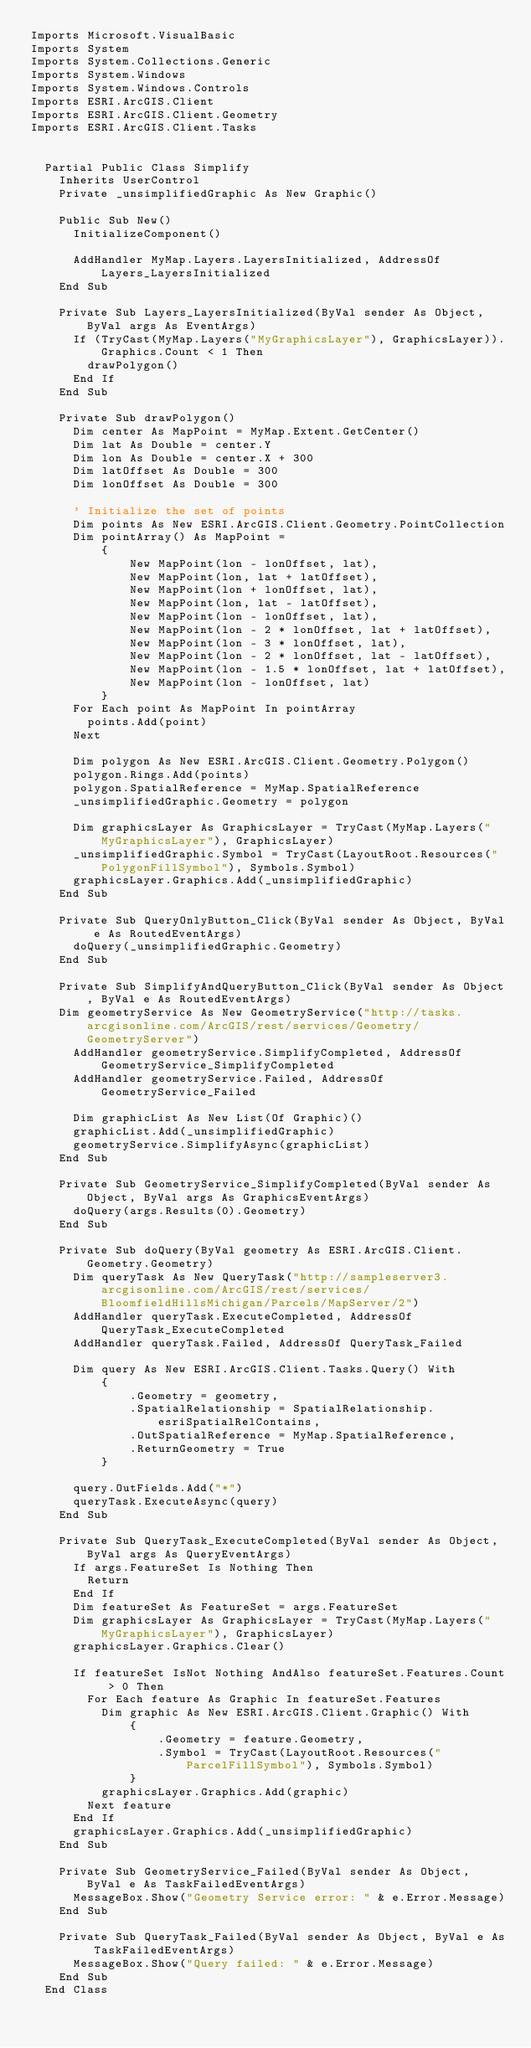<code> <loc_0><loc_0><loc_500><loc_500><_VisualBasic_>Imports Microsoft.VisualBasic
Imports System
Imports System.Collections.Generic
Imports System.Windows
Imports System.Windows.Controls
Imports ESRI.ArcGIS.Client
Imports ESRI.ArcGIS.Client.Geometry
Imports ESRI.ArcGIS.Client.Tasks


  Partial Public Class Simplify
    Inherits UserControl
    Private _unsimplifiedGraphic As New Graphic()

    Public Sub New()
      InitializeComponent()

      AddHandler MyMap.Layers.LayersInitialized, AddressOf Layers_LayersInitialized
    End Sub

    Private Sub Layers_LayersInitialized(ByVal sender As Object, ByVal args As EventArgs)
      If (TryCast(MyMap.Layers("MyGraphicsLayer"), GraphicsLayer)).Graphics.Count < 1 Then
        drawPolygon()
      End If
    End Sub

    Private Sub drawPolygon()
      Dim center As MapPoint = MyMap.Extent.GetCenter()
      Dim lat As Double = center.Y
      Dim lon As Double = center.X + 300
      Dim latOffset As Double = 300
      Dim lonOffset As Double = 300

      ' Initialize the set of points
      Dim points As New ESRI.ArcGIS.Client.Geometry.PointCollection
      Dim pointArray() As MapPoint =
          {
              New MapPoint(lon - lonOffset, lat),
              New MapPoint(lon, lat + latOffset),
              New MapPoint(lon + lonOffset, lat),
              New MapPoint(lon, lat - latOffset),
              New MapPoint(lon - lonOffset, lat),
              New MapPoint(lon - 2 * lonOffset, lat + latOffset),
              New MapPoint(lon - 3 * lonOffset, lat),
              New MapPoint(lon - 2 * lonOffset, lat - latOffset),
              New MapPoint(lon - 1.5 * lonOffset, lat + latOffset),
              New MapPoint(lon - lonOffset, lat)
          }
      For Each point As MapPoint In pointArray
        points.Add(point)
      Next

      Dim polygon As New ESRI.ArcGIS.Client.Geometry.Polygon()
      polygon.Rings.Add(points)
      polygon.SpatialReference = MyMap.SpatialReference
      _unsimplifiedGraphic.Geometry = polygon

      Dim graphicsLayer As GraphicsLayer = TryCast(MyMap.Layers("MyGraphicsLayer"), GraphicsLayer)
      _unsimplifiedGraphic.Symbol = TryCast(LayoutRoot.Resources("PolygonFillSymbol"), Symbols.Symbol)
      graphicsLayer.Graphics.Add(_unsimplifiedGraphic)
    End Sub

    Private Sub QueryOnlyButton_Click(ByVal sender As Object, ByVal e As RoutedEventArgs)
      doQuery(_unsimplifiedGraphic.Geometry)
    End Sub

    Private Sub SimplifyAndQueryButton_Click(ByVal sender As Object, ByVal e As RoutedEventArgs)
		Dim geometryService As New GeometryService("http://tasks.arcgisonline.com/ArcGIS/rest/services/Geometry/GeometryServer")
      AddHandler geometryService.SimplifyCompleted, AddressOf GeometryService_SimplifyCompleted
      AddHandler geometryService.Failed, AddressOf GeometryService_Failed

      Dim graphicList As New List(Of Graphic)()
      graphicList.Add(_unsimplifiedGraphic)
      geometryService.SimplifyAsync(graphicList)
    End Sub

    Private Sub GeometryService_SimplifyCompleted(ByVal sender As Object, ByVal args As GraphicsEventArgs)
      doQuery(args.Results(0).Geometry)
    End Sub

    Private Sub doQuery(ByVal geometry As ESRI.ArcGIS.Client.Geometry.Geometry)
      Dim queryTask As New QueryTask("http://sampleserver3.arcgisonline.com/ArcGIS/rest/services/BloomfieldHillsMichigan/Parcels/MapServer/2")
      AddHandler queryTask.ExecuteCompleted, AddressOf QueryTask_ExecuteCompleted
      AddHandler queryTask.Failed, AddressOf QueryTask_Failed

      Dim query As New ESRI.ArcGIS.Client.Tasks.Query() With
          {
              .Geometry = geometry,
              .SpatialRelationship = SpatialRelationship.esriSpatialRelContains,
              .OutSpatialReference = MyMap.SpatialReference,
              .ReturnGeometry = True
          }

      query.OutFields.Add("*")
      queryTask.ExecuteAsync(query)
    End Sub

    Private Sub QueryTask_ExecuteCompleted(ByVal sender As Object, ByVal args As QueryEventArgs)
      If args.FeatureSet Is Nothing Then
        Return
      End If
      Dim featureSet As FeatureSet = args.FeatureSet
      Dim graphicsLayer As GraphicsLayer = TryCast(MyMap.Layers("MyGraphicsLayer"), GraphicsLayer)
      graphicsLayer.Graphics.Clear()

      If featureSet IsNot Nothing AndAlso featureSet.Features.Count > 0 Then
        For Each feature As Graphic In featureSet.Features
          Dim graphic As New ESRI.ArcGIS.Client.Graphic() With
              {
                  .Geometry = feature.Geometry,
                  .Symbol = TryCast(LayoutRoot.Resources("ParcelFillSymbol"), Symbols.Symbol)
              }
          graphicsLayer.Graphics.Add(graphic)
        Next feature
      End If
      graphicsLayer.Graphics.Add(_unsimplifiedGraphic)
    End Sub

    Private Sub GeometryService_Failed(ByVal sender As Object, ByVal e As TaskFailedEventArgs)
      MessageBox.Show("Geometry Service error: " & e.Error.Message)
    End Sub

    Private Sub QueryTask_Failed(ByVal sender As Object, ByVal e As TaskFailedEventArgs)
      MessageBox.Show("Query failed: " & e.Error.Message)
    End Sub
  End Class

</code> 